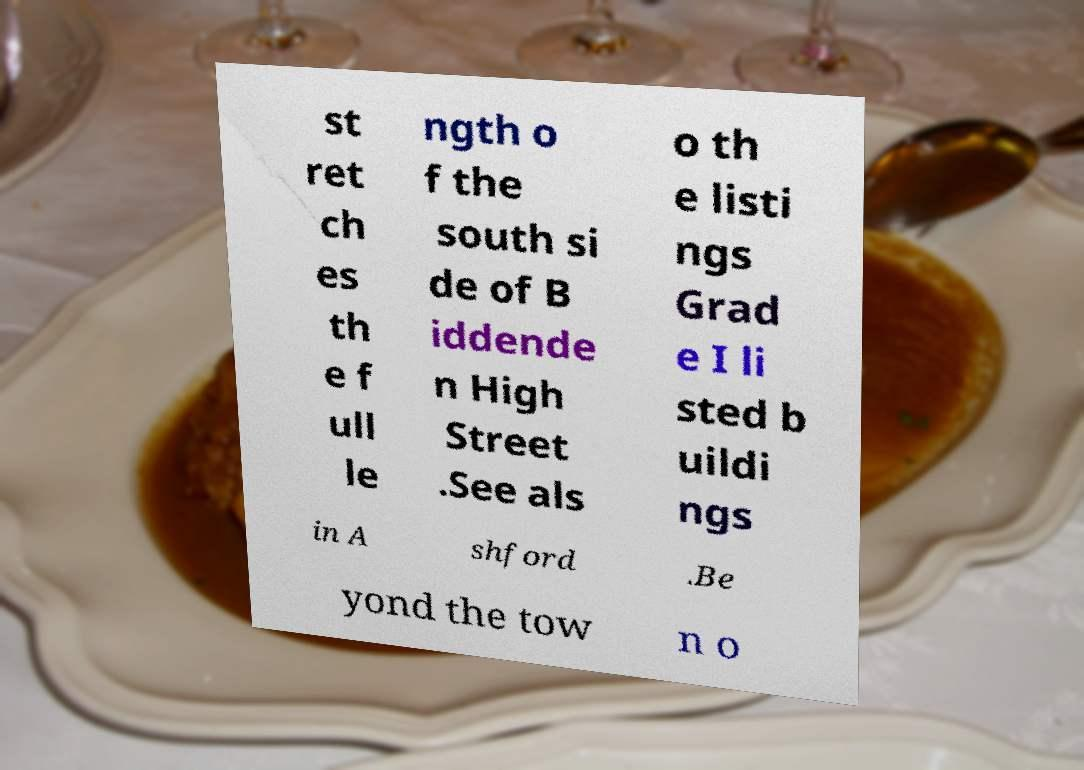Can you read and provide the text displayed in the image?This photo seems to have some interesting text. Can you extract and type it out for me? st ret ch es th e f ull le ngth o f the south si de of B iddende n High Street .See als o th e listi ngs Grad e I li sted b uildi ngs in A shford .Be yond the tow n o 